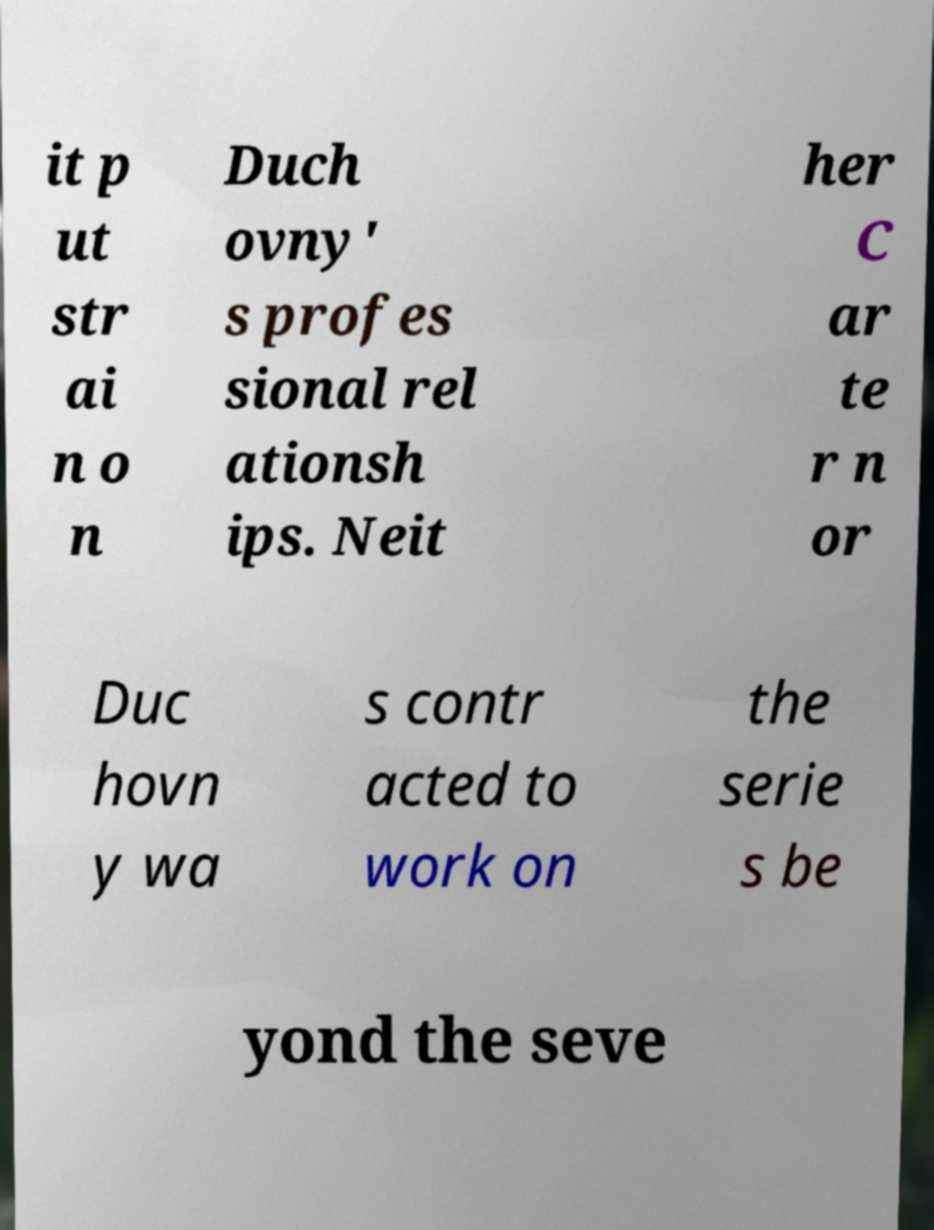Please read and relay the text visible in this image. What does it say? it p ut str ai n o n Duch ovny' s profes sional rel ationsh ips. Neit her C ar te r n or Duc hovn y wa s contr acted to work on the serie s be yond the seve 